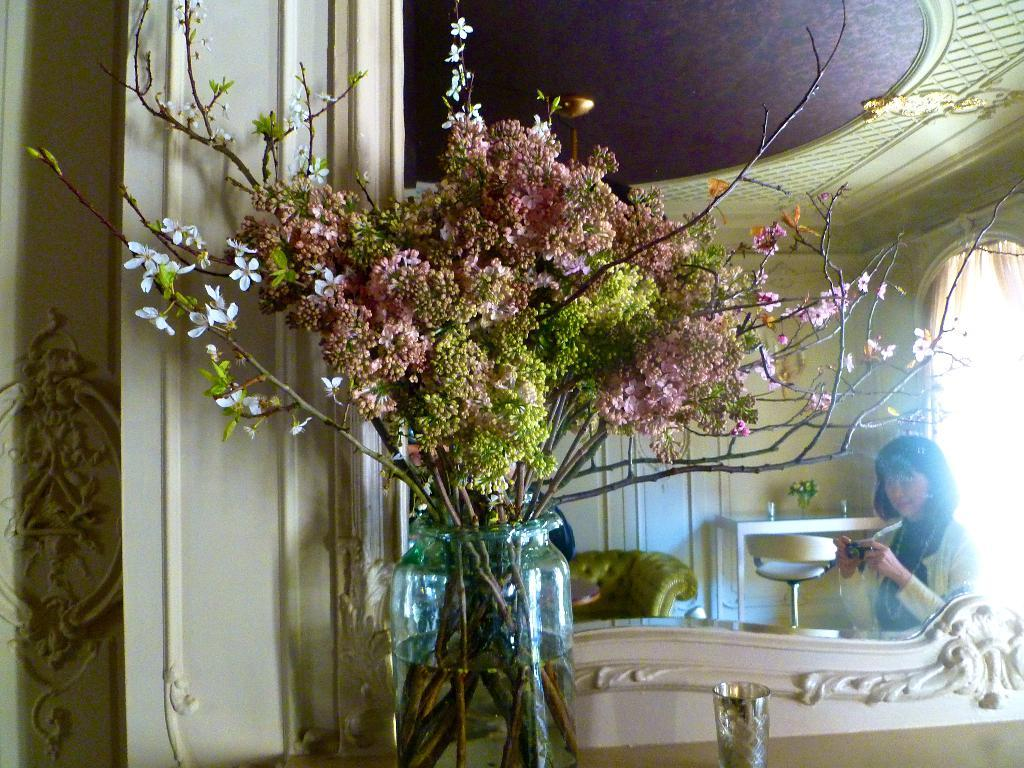Who is present in the image? There is a woman in the image. What is the woman holding in the image? The woman is holding a camera. What type of furniture can be seen in the image? There are side tables and a sofa set in the image. What decorative items are on the side tables? There are flower vases on the side tables. What type of cork can be seen on the sofa in the image? There is no cork visible on the sofa in the image. What color is the sheet draped over the woman's head in the image? There is no sheet present in the image; the woman is holding a camera. 